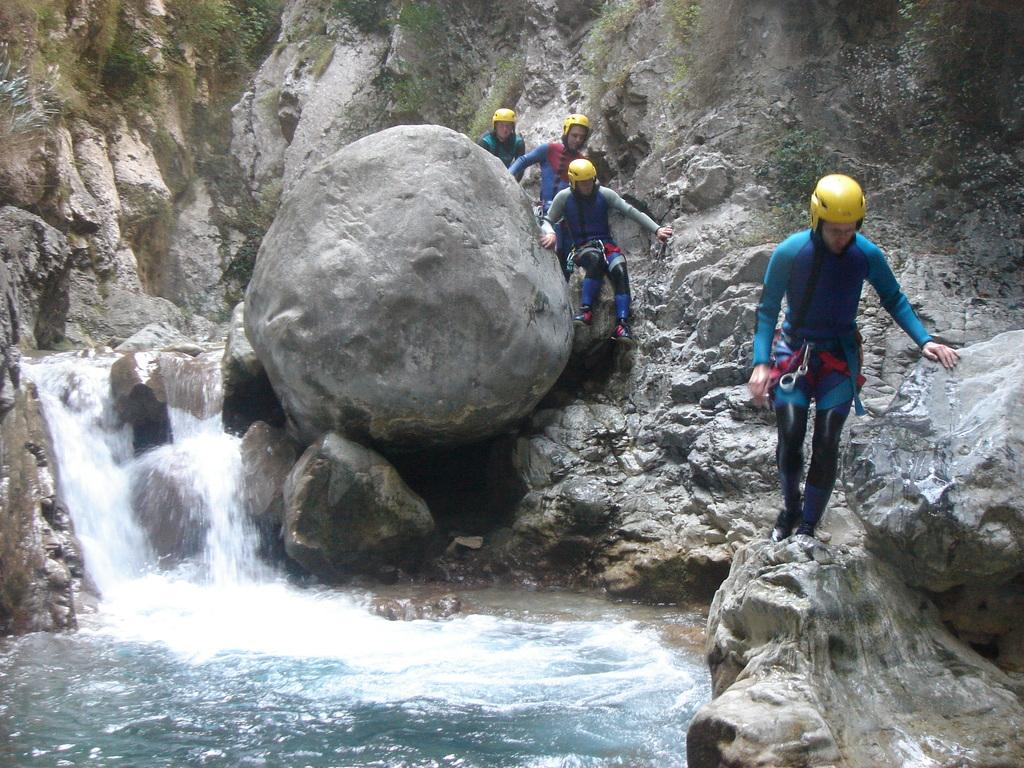How many people are in the image? There are four people in the image. What activity are the people engaged in? The people are canyoning. What type of terrain can be seen in the image? There are rocks visible in the image. What natural feature is present in the image? There is water in the image, and there are waterfalls as well. Where can trees be found in the image? Trees are present in the top right corner of the image. What type of plants are growing in the basket in the image? There is no basket or plants present in the image. How many clocks can be seen in the image? There are no clocks visible in the image. 